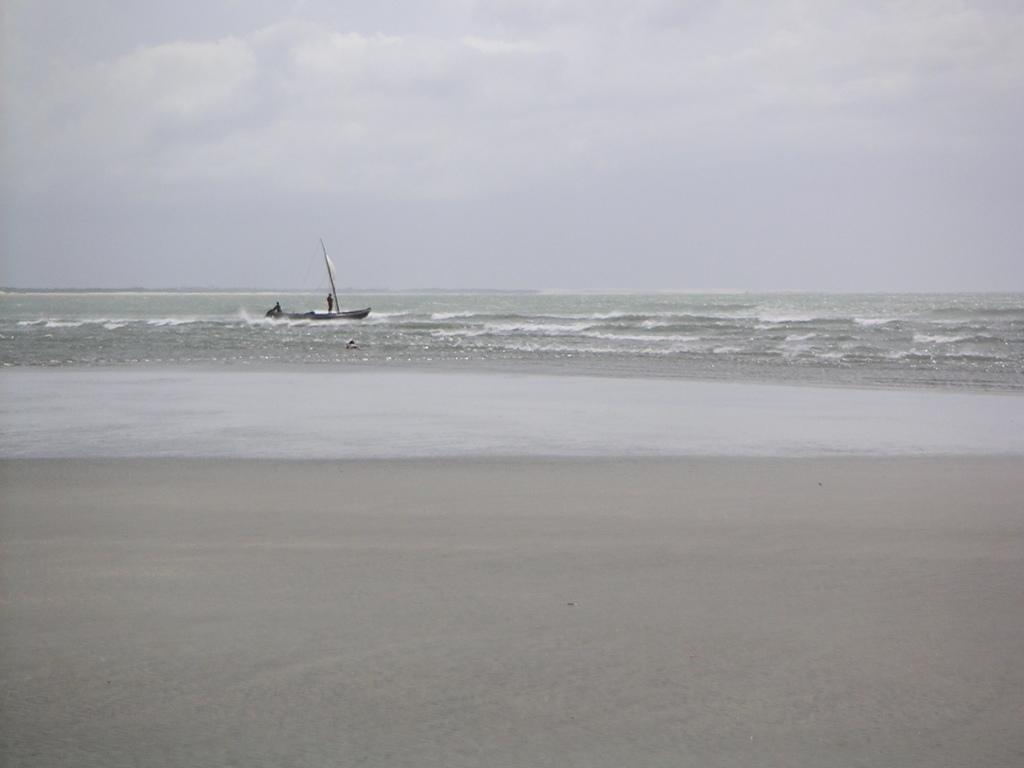What is the main subject of the image? The main subject of the image is a boat. Where is the boat located in the image? The boat is on the water surface in the image. Are there any people present in the image? Yes, there are people on the boat in the image. What is visible at the top side of the image? The sky is visible at the top side of the image. What type of spade can be seen being used by the people on the boat in the image? There is no spade present in the image, and therefore no such activity can be observed. Can you tell me how many clovers are visible on the boat in the image? There are no clovers present on the boat in the image. 